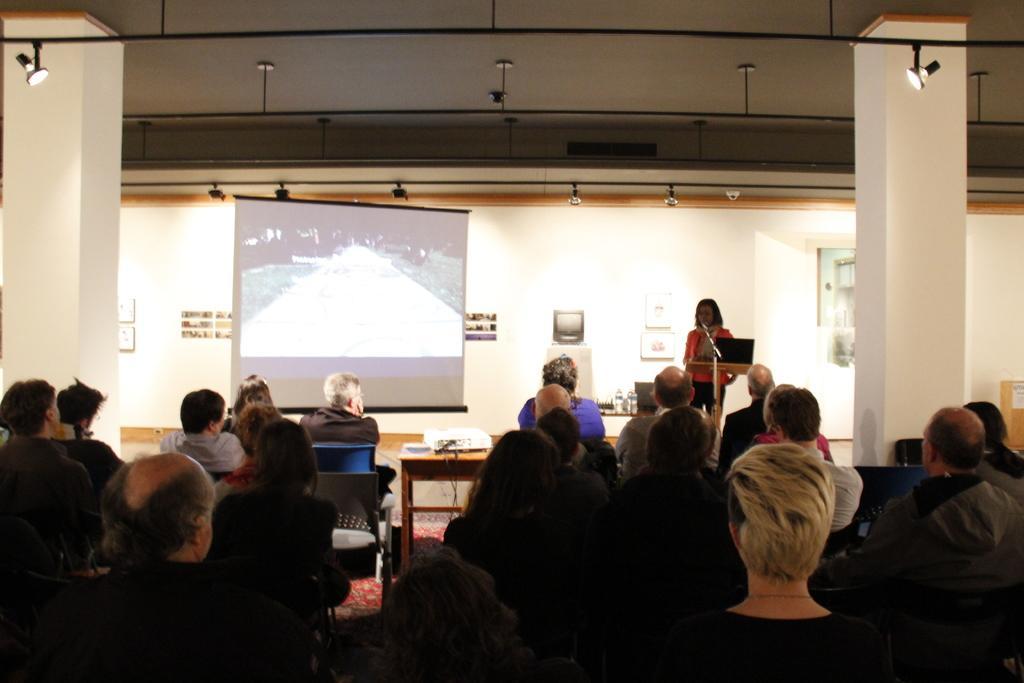Could you give a brief overview of what you see in this image? A group of people are sitting on a chair in front of a table. I can also see there is a projector screen and a woman standing. 